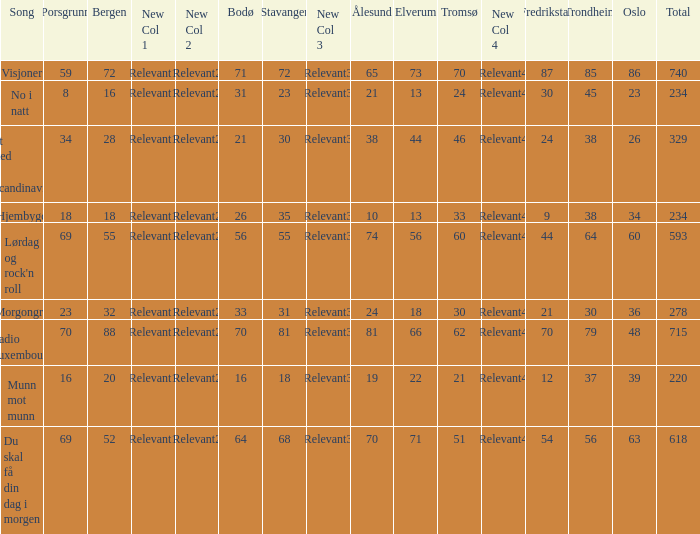When oslo is 48, what is stavanger? 81.0. 